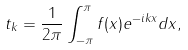<formula> <loc_0><loc_0><loc_500><loc_500>t _ { k } = \frac { 1 } { 2 \pi } \int _ { - \pi } ^ { \pi } f ( x ) e ^ { - i k x } d x ,</formula> 